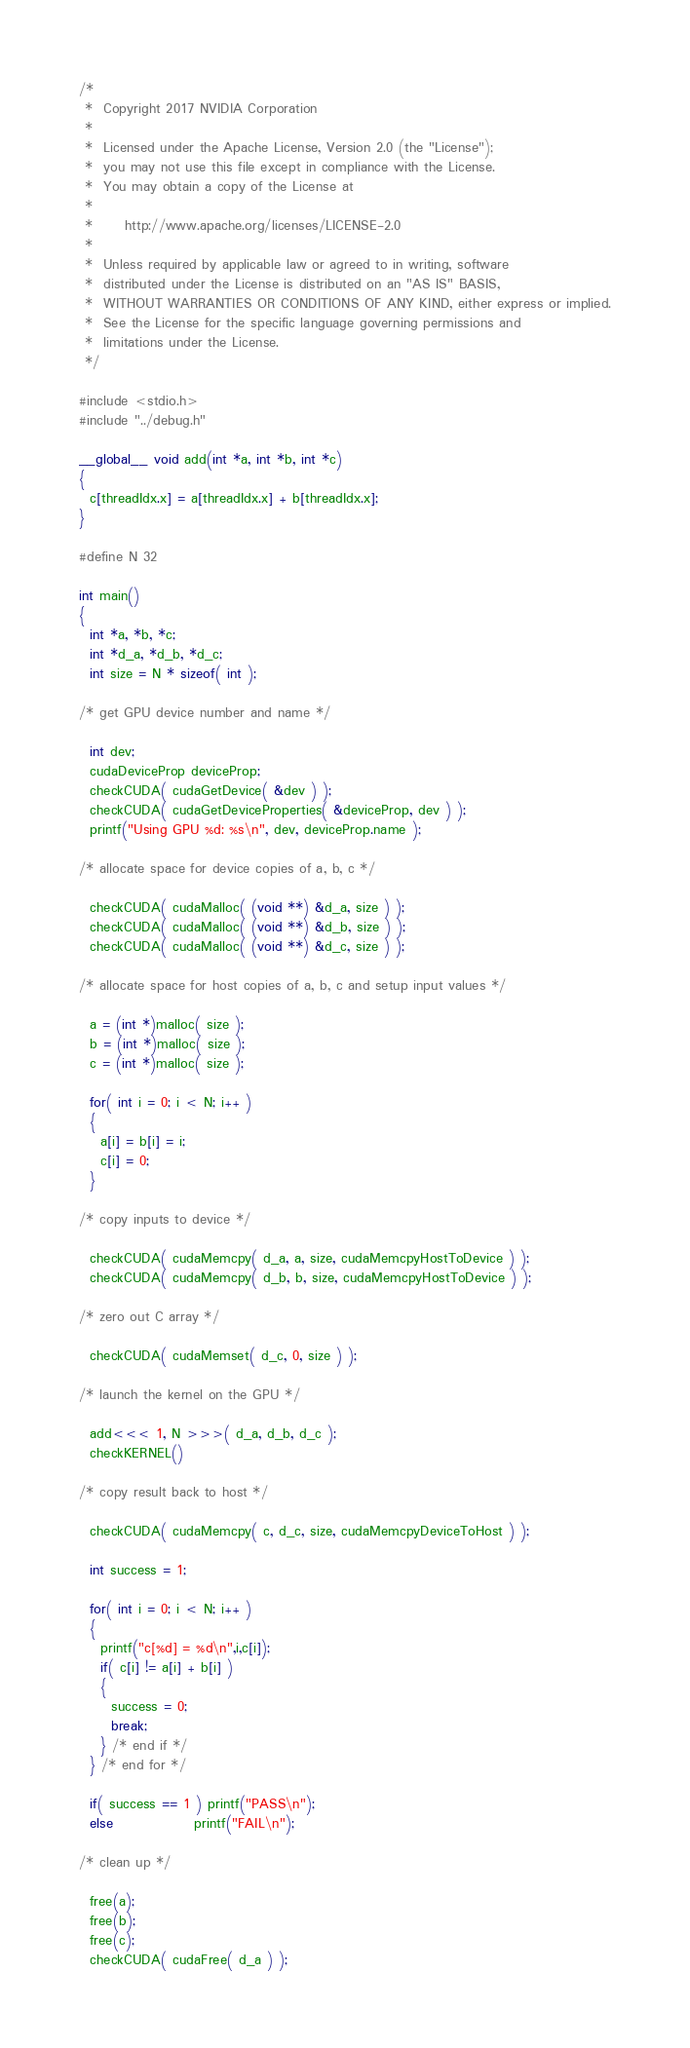<code> <loc_0><loc_0><loc_500><loc_500><_Cuda_>/*
 *  Copyright 2017 NVIDIA Corporation
 *
 *  Licensed under the Apache License, Version 2.0 (the "License");
 *  you may not use this file except in compliance with the License.
 *  You may obtain a copy of the License at
 *
 *      http://www.apache.org/licenses/LICENSE-2.0
 *
 *  Unless required by applicable law or agreed to in writing, software
 *  distributed under the License is distributed on an "AS IS" BASIS,
 *  WITHOUT WARRANTIES OR CONDITIONS OF ANY KIND, either express or implied.
 *  See the License for the specific language governing permissions and
 *  limitations under the License.
 */

#include <stdio.h>
#include "../debug.h"

__global__ void add(int *a, int *b, int *c)
{
  c[threadIdx.x] = a[threadIdx.x] + b[threadIdx.x];
}

#define N 32

int main()
{
  int *a, *b, *c;
  int *d_a, *d_b, *d_c;
  int size = N * sizeof( int );

/* get GPU device number and name */

  int dev;
  cudaDeviceProp deviceProp;
  checkCUDA( cudaGetDevice( &dev ) );
  checkCUDA( cudaGetDeviceProperties( &deviceProp, dev ) );
  printf("Using GPU %d: %s\n", dev, deviceProp.name );

/* allocate space for device copies of a, b, c */

  checkCUDA( cudaMalloc( (void **) &d_a, size ) );
  checkCUDA( cudaMalloc( (void **) &d_b, size ) );
  checkCUDA( cudaMalloc( (void **) &d_c, size ) );

/* allocate space for host copies of a, b, c and setup input values */

  a = (int *)malloc( size );
  b = (int *)malloc( size );
  c = (int *)malloc( size );

  for( int i = 0; i < N; i++ )
  {
    a[i] = b[i] = i;
    c[i] = 0;
  }

/* copy inputs to device */

  checkCUDA( cudaMemcpy( d_a, a, size, cudaMemcpyHostToDevice ) );
  checkCUDA( cudaMemcpy( d_b, b, size, cudaMemcpyHostToDevice ) );

/* zero out C array */
 
  checkCUDA( cudaMemset( d_c, 0, size ) );

/* launch the kernel on the GPU */

  add<<< 1, N >>>( d_a, d_b, d_c );
  checkKERNEL()

/* copy result back to host */

  checkCUDA( cudaMemcpy( c, d_c, size, cudaMemcpyDeviceToHost ) );

  int success = 1;

  for( int i = 0; i < N; i++ )
  {
    printf("c[%d] = %d\n",i,c[i]);
    if( c[i] != a[i] + b[i] )
    {
      success = 0;
      break;
    } /* end if */
  } /* end for */

  if( success == 1 ) printf("PASS\n");
  else               printf("FAIL\n");

/* clean up */

  free(a);
  free(b);
  free(c);
  checkCUDA( cudaFree( d_a ) );</code> 